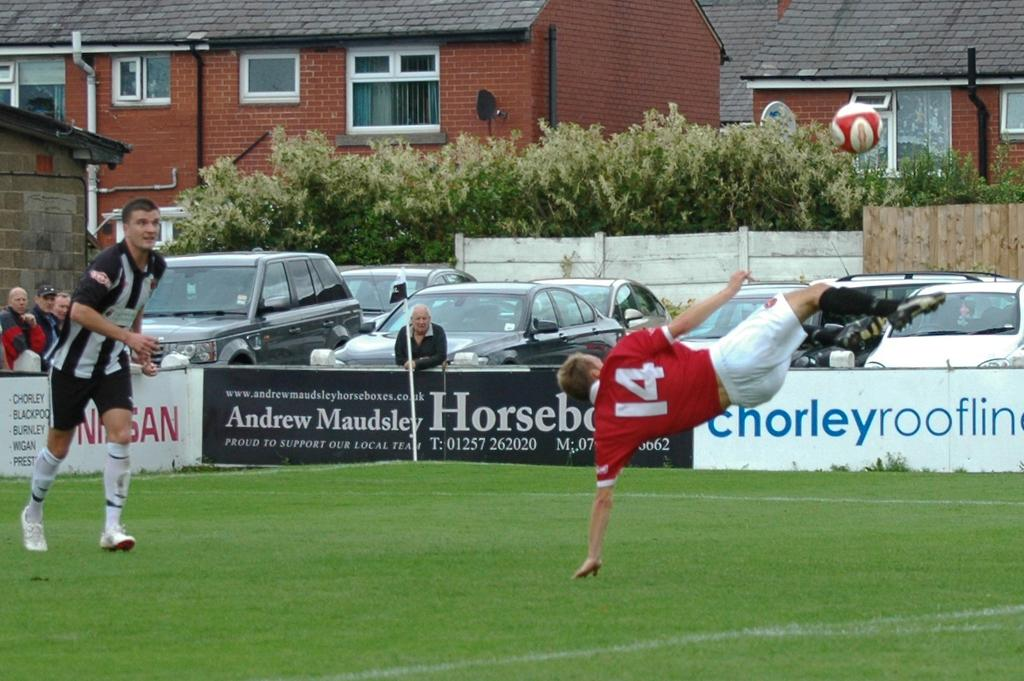Provide a one-sentence caption for the provided image. the man wearing number 14 red jersey is kicking the ball. 